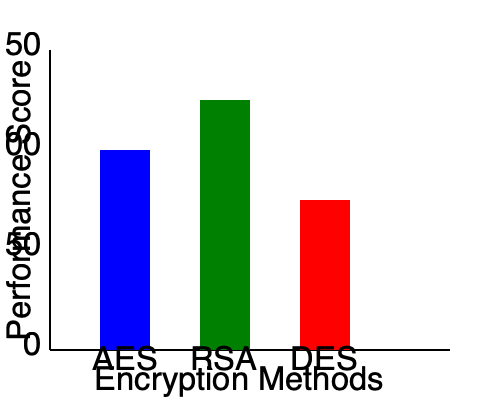As a product manager collaborating with the software engineering team, you are evaluating different encryption methods for a new security solution. Based on the performance chart provided, which encryption method would you recommend to the team for implementation, and why? To answer this question, we need to analyze the performance chart and consider the implications for our security solution. Let's break it down step-by-step:

1. Interpret the chart:
   - The y-axis represents the performance score, with higher scores indicating better performance.
   - The x-axis shows three encryption methods: AES, RSA, and DES.

2. Compare the performance scores:
   - AES: Approximately 100
   - RSA: Approximately 125
   - DES: Approximately 75

3. Consider the strengths of each method:
   - AES (Advanced Encryption Standard): Known for its speed and efficiency in symmetric encryption.
   - RSA (Rivest-Shamir-Adleman): An asymmetric encryption algorithm, suitable for key exchange and digital signatures.
   - DES (Data Encryption Standard): An older symmetric encryption algorithm, generally considered less secure than AES.

4. Analyze the results:
   - RSA shows the highest performance score, but it's important to note that RSA is typically slower for large data encryption compared to symmetric algorithms.
   - AES has the second-highest score and is widely regarded as a secure and efficient symmetric encryption method.
   - DES has the lowest score and is generally considered outdated in modern cryptography.

5. Consider the product requirements:
   - As a product manager, you need to balance performance with security and industry standards.
   - AES is the current industry standard for symmetric encryption and is approved by many regulatory bodies.

6. Make a recommendation:
   - Given AES's high performance score, industry acceptance, and suitability for efficient data encryption, it would be the most appropriate choice for implementation in most security solutions.
Answer: AES, due to its high performance score, industry acceptance, and efficient symmetric encryption capabilities. 